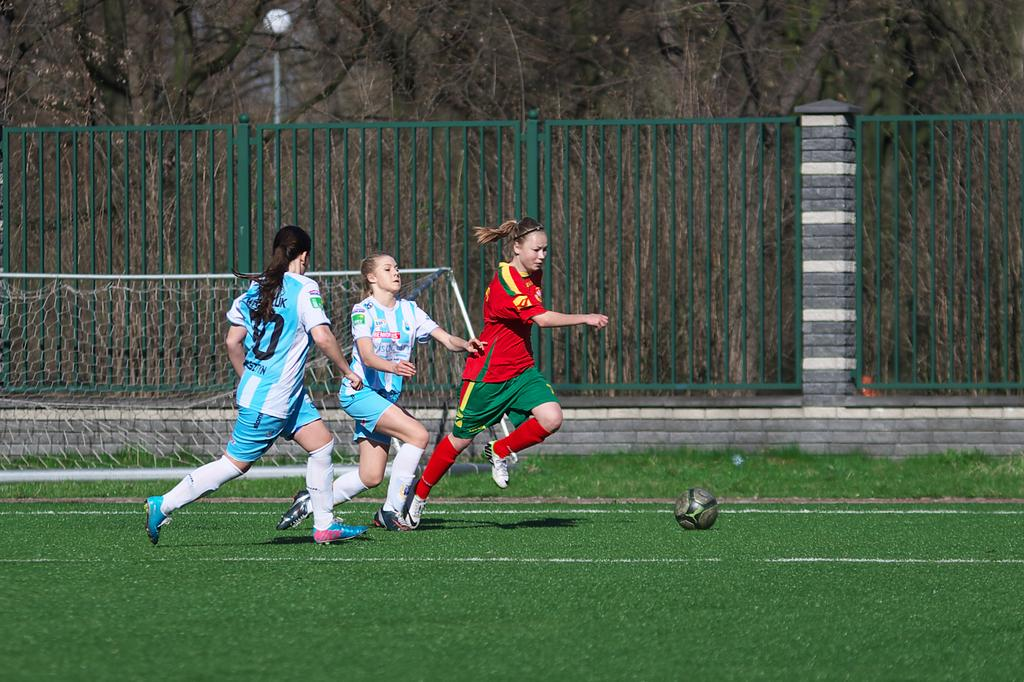<image>
Summarize the visual content of the image. three soccer players with one wearing the number 70 jersey 